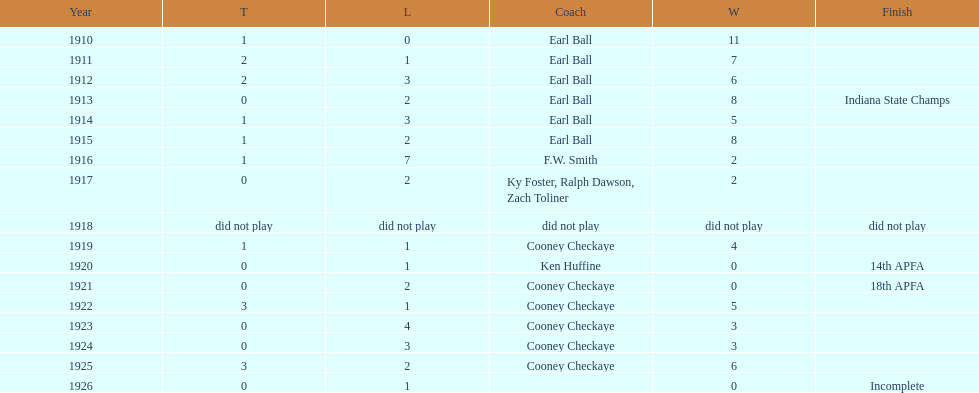Who coached the muncie flyers to an indiana state championship? Earl Ball. 